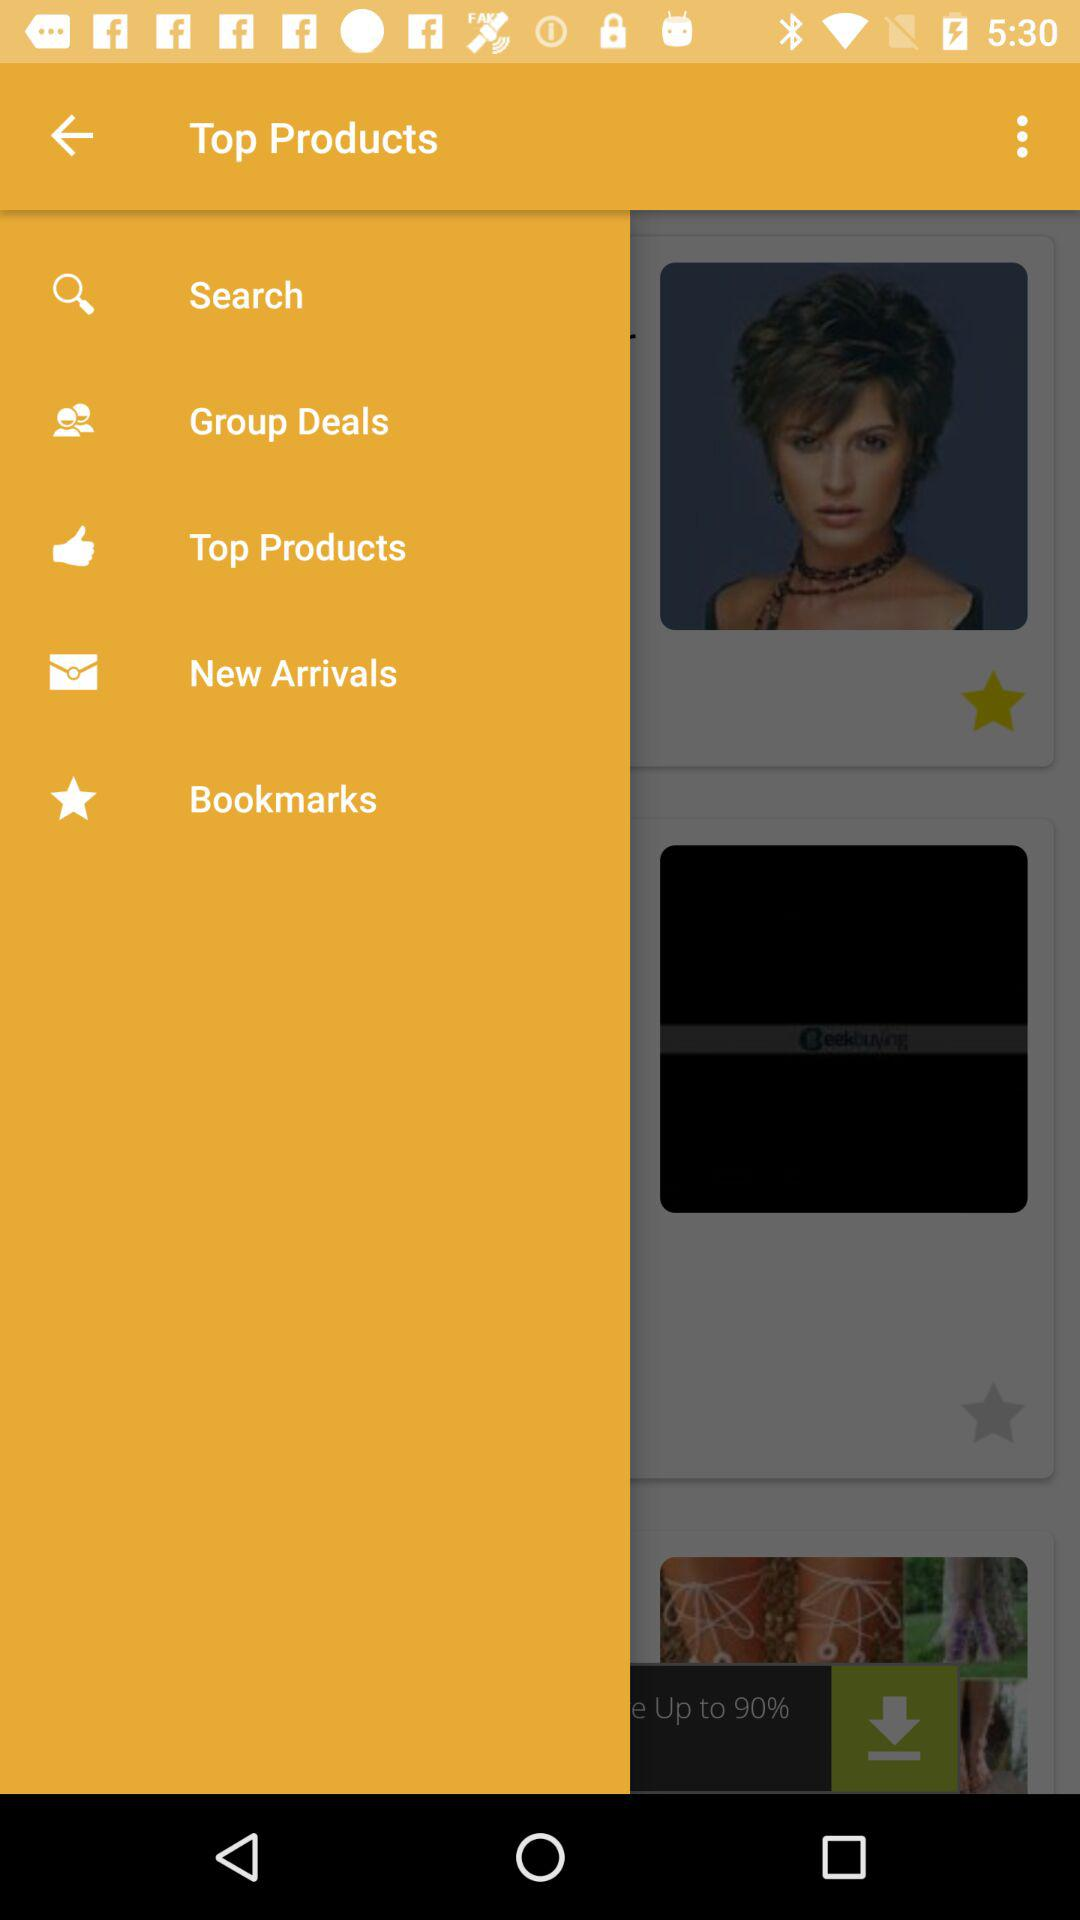What is the application name?
When the provided information is insufficient, respond with <no answer>. <no answer> 